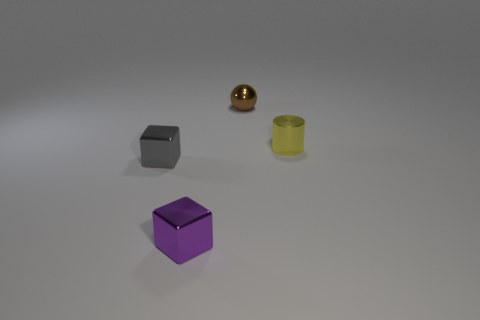Is there anything else that is the same material as the small brown object? Yes, the object on the far right appears to be made of a similar polished metallic material as the small brown object in the middle. 